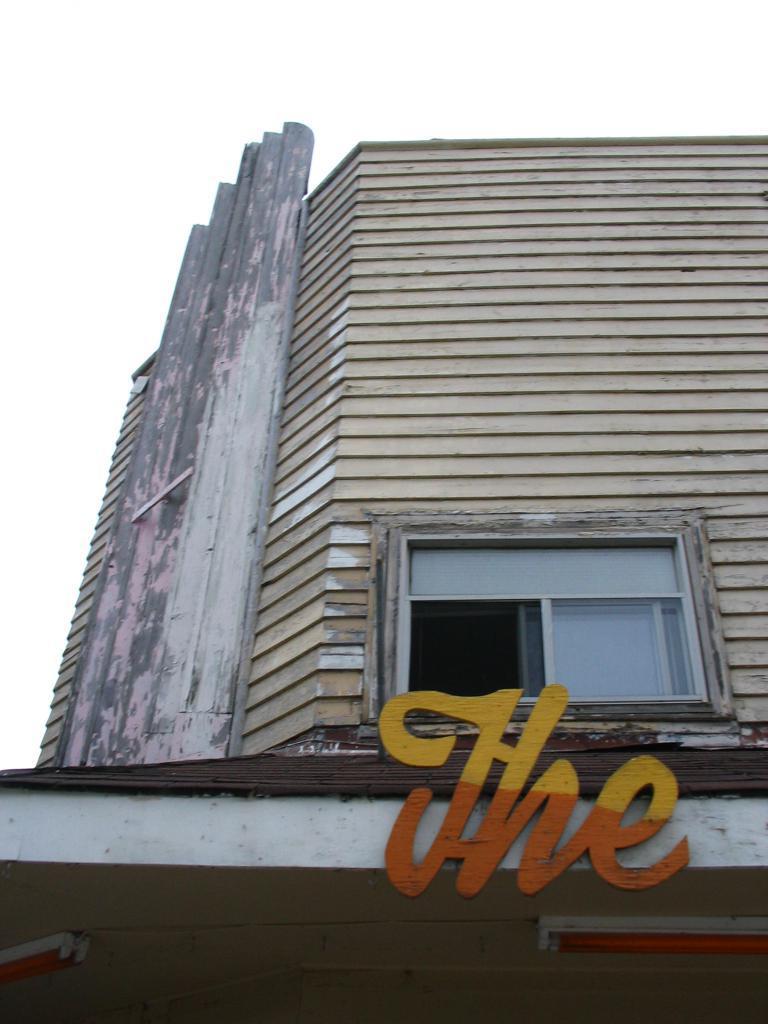In one or two sentences, can you explain what this image depicts? In this image there is a building and there is a text on the wall of the building which is visible and the sky is cloudy. 